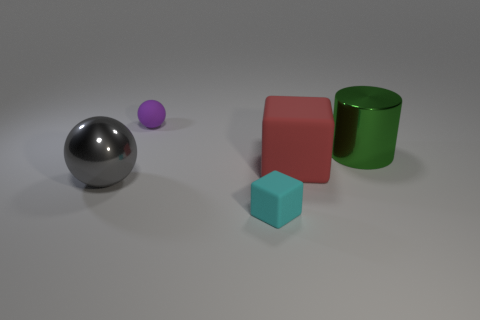What textures are visible on the objects? The objects exhibit a variety of textures: the spheres and the cylinder have smooth and reflective surfaces indicating a metallic or polished texture, while the cubes have a matte finish, indicating a non-reflective or possibly a rough texture. Is there a source of light in the image? While a specific light source is not visible in the image, the reflections and shadows on the objects suggest an overhead light source, possibly diffused to create soft shadows. 